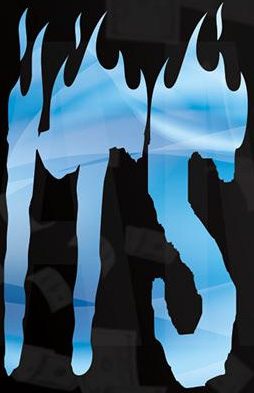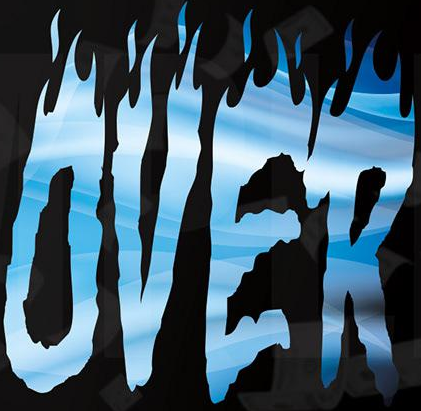Read the text from these images in sequence, separated by a semicolon. ITS; OVER 